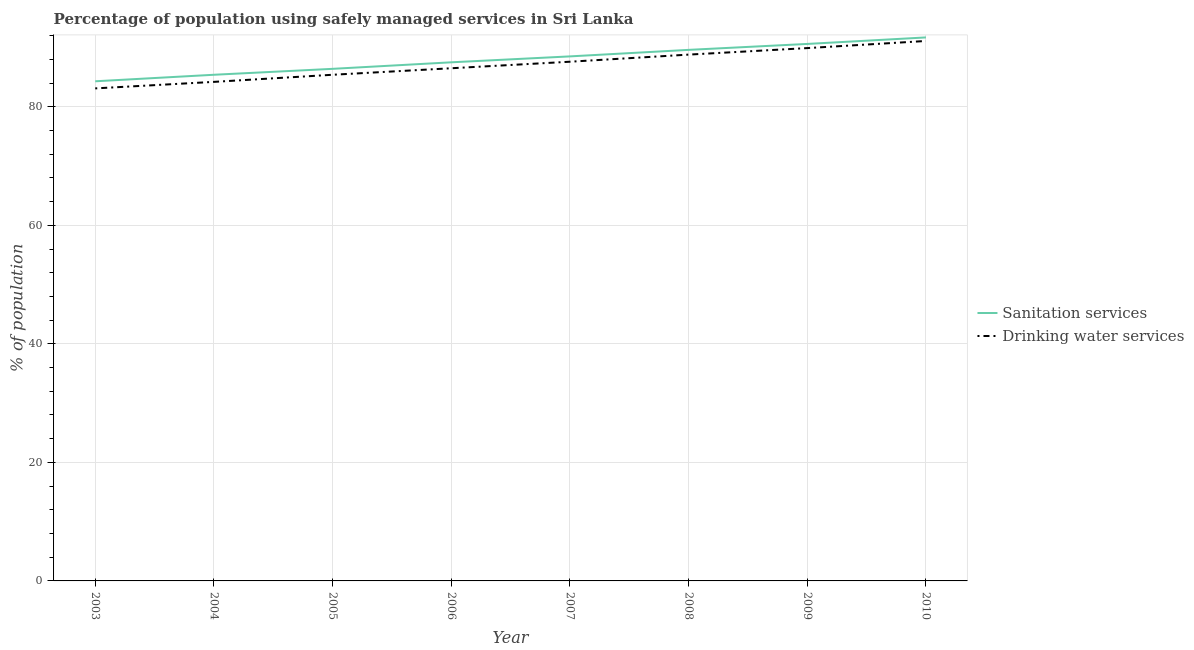Is the number of lines equal to the number of legend labels?
Your answer should be very brief. Yes. What is the percentage of population who used sanitation services in 2008?
Provide a short and direct response. 89.6. Across all years, what is the maximum percentage of population who used sanitation services?
Make the answer very short. 91.7. Across all years, what is the minimum percentage of population who used sanitation services?
Your response must be concise. 84.3. In which year was the percentage of population who used sanitation services minimum?
Provide a succinct answer. 2003. What is the total percentage of population who used drinking water services in the graph?
Offer a terse response. 696.6. What is the difference between the percentage of population who used sanitation services in 2003 and that in 2006?
Your answer should be compact. -3.2. What is the average percentage of population who used sanitation services per year?
Offer a very short reply. 88. In the year 2003, what is the difference between the percentage of population who used sanitation services and percentage of population who used drinking water services?
Keep it short and to the point. 1.2. What is the ratio of the percentage of population who used drinking water services in 2005 to that in 2008?
Make the answer very short. 0.96. Is the difference between the percentage of population who used drinking water services in 2005 and 2009 greater than the difference between the percentage of population who used sanitation services in 2005 and 2009?
Offer a terse response. No. What is the difference between the highest and the second highest percentage of population who used drinking water services?
Make the answer very short. 1.2. What is the difference between the highest and the lowest percentage of population who used sanitation services?
Offer a terse response. 7.4. Does the percentage of population who used sanitation services monotonically increase over the years?
Your answer should be very brief. Yes. Is the percentage of population who used drinking water services strictly greater than the percentage of population who used sanitation services over the years?
Your answer should be compact. No. How many lines are there?
Your answer should be compact. 2. Are the values on the major ticks of Y-axis written in scientific E-notation?
Your answer should be very brief. No. Does the graph contain grids?
Your response must be concise. Yes. What is the title of the graph?
Your answer should be very brief. Percentage of population using safely managed services in Sri Lanka. What is the label or title of the Y-axis?
Your answer should be compact. % of population. What is the % of population in Sanitation services in 2003?
Provide a short and direct response. 84.3. What is the % of population in Drinking water services in 2003?
Provide a short and direct response. 83.1. What is the % of population of Sanitation services in 2004?
Provide a short and direct response. 85.4. What is the % of population of Drinking water services in 2004?
Your response must be concise. 84.2. What is the % of population in Sanitation services in 2005?
Ensure brevity in your answer.  86.4. What is the % of population of Drinking water services in 2005?
Offer a very short reply. 85.4. What is the % of population in Sanitation services in 2006?
Offer a terse response. 87.5. What is the % of population in Drinking water services in 2006?
Your answer should be compact. 86.5. What is the % of population of Sanitation services in 2007?
Make the answer very short. 88.5. What is the % of population of Drinking water services in 2007?
Provide a succinct answer. 87.6. What is the % of population of Sanitation services in 2008?
Make the answer very short. 89.6. What is the % of population in Drinking water services in 2008?
Provide a succinct answer. 88.8. What is the % of population in Sanitation services in 2009?
Ensure brevity in your answer.  90.6. What is the % of population of Drinking water services in 2009?
Give a very brief answer. 89.9. What is the % of population of Sanitation services in 2010?
Make the answer very short. 91.7. What is the % of population in Drinking water services in 2010?
Keep it short and to the point. 91.1. Across all years, what is the maximum % of population of Sanitation services?
Your answer should be very brief. 91.7. Across all years, what is the maximum % of population of Drinking water services?
Provide a short and direct response. 91.1. Across all years, what is the minimum % of population in Sanitation services?
Keep it short and to the point. 84.3. Across all years, what is the minimum % of population in Drinking water services?
Your answer should be very brief. 83.1. What is the total % of population of Sanitation services in the graph?
Keep it short and to the point. 704. What is the total % of population of Drinking water services in the graph?
Keep it short and to the point. 696.6. What is the difference between the % of population in Sanitation services in 2003 and that in 2004?
Your answer should be compact. -1.1. What is the difference between the % of population in Drinking water services in 2003 and that in 2005?
Offer a terse response. -2.3. What is the difference between the % of population of Sanitation services in 2003 and that in 2006?
Offer a very short reply. -3.2. What is the difference between the % of population in Drinking water services in 2003 and that in 2006?
Make the answer very short. -3.4. What is the difference between the % of population of Sanitation services in 2003 and that in 2007?
Offer a very short reply. -4.2. What is the difference between the % of population in Drinking water services in 2003 and that in 2007?
Make the answer very short. -4.5. What is the difference between the % of population in Drinking water services in 2003 and that in 2009?
Make the answer very short. -6.8. What is the difference between the % of population in Sanitation services in 2004 and that in 2005?
Give a very brief answer. -1. What is the difference between the % of population in Sanitation services in 2004 and that in 2006?
Give a very brief answer. -2.1. What is the difference between the % of population of Sanitation services in 2004 and that in 2008?
Your answer should be compact. -4.2. What is the difference between the % of population of Drinking water services in 2004 and that in 2008?
Make the answer very short. -4.6. What is the difference between the % of population in Sanitation services in 2004 and that in 2009?
Offer a very short reply. -5.2. What is the difference between the % of population in Drinking water services in 2004 and that in 2010?
Provide a short and direct response. -6.9. What is the difference between the % of population of Sanitation services in 2005 and that in 2006?
Your answer should be very brief. -1.1. What is the difference between the % of population in Sanitation services in 2005 and that in 2008?
Provide a succinct answer. -3.2. What is the difference between the % of population in Sanitation services in 2005 and that in 2010?
Offer a terse response. -5.3. What is the difference between the % of population in Drinking water services in 2005 and that in 2010?
Offer a terse response. -5.7. What is the difference between the % of population of Drinking water services in 2006 and that in 2007?
Provide a short and direct response. -1.1. What is the difference between the % of population in Drinking water services in 2006 and that in 2008?
Make the answer very short. -2.3. What is the difference between the % of population of Sanitation services in 2006 and that in 2009?
Provide a short and direct response. -3.1. What is the difference between the % of population in Drinking water services in 2006 and that in 2009?
Offer a terse response. -3.4. What is the difference between the % of population of Sanitation services in 2007 and that in 2009?
Offer a very short reply. -2.1. What is the difference between the % of population in Sanitation services in 2007 and that in 2010?
Your answer should be compact. -3.2. What is the difference between the % of population in Sanitation services in 2008 and that in 2009?
Provide a succinct answer. -1. What is the difference between the % of population of Drinking water services in 2008 and that in 2009?
Ensure brevity in your answer.  -1.1. What is the difference between the % of population in Sanitation services in 2008 and that in 2010?
Your response must be concise. -2.1. What is the difference between the % of population of Drinking water services in 2008 and that in 2010?
Provide a short and direct response. -2.3. What is the difference between the % of population in Sanitation services in 2009 and that in 2010?
Your answer should be very brief. -1.1. What is the difference between the % of population in Sanitation services in 2003 and the % of population in Drinking water services in 2004?
Your response must be concise. 0.1. What is the difference between the % of population in Sanitation services in 2003 and the % of population in Drinking water services in 2008?
Make the answer very short. -4.5. What is the difference between the % of population of Sanitation services in 2003 and the % of population of Drinking water services in 2009?
Keep it short and to the point. -5.6. What is the difference between the % of population in Sanitation services in 2004 and the % of population in Drinking water services in 2005?
Provide a short and direct response. 0. What is the difference between the % of population in Sanitation services in 2004 and the % of population in Drinking water services in 2009?
Offer a terse response. -4.5. What is the difference between the % of population in Sanitation services in 2004 and the % of population in Drinking water services in 2010?
Your answer should be very brief. -5.7. What is the difference between the % of population of Sanitation services in 2005 and the % of population of Drinking water services in 2008?
Offer a very short reply. -2.4. What is the difference between the % of population of Sanitation services in 2006 and the % of population of Drinking water services in 2007?
Keep it short and to the point. -0.1. What is the difference between the % of population in Sanitation services in 2006 and the % of population in Drinking water services in 2008?
Your answer should be compact. -1.3. What is the difference between the % of population in Sanitation services in 2007 and the % of population in Drinking water services in 2008?
Your response must be concise. -0.3. What is the difference between the % of population in Sanitation services in 2007 and the % of population in Drinking water services in 2009?
Offer a terse response. -1.4. What is the average % of population of Drinking water services per year?
Your answer should be compact. 87.08. In the year 2004, what is the difference between the % of population in Sanitation services and % of population in Drinking water services?
Provide a succinct answer. 1.2. In the year 2007, what is the difference between the % of population in Sanitation services and % of population in Drinking water services?
Your response must be concise. 0.9. In the year 2008, what is the difference between the % of population in Sanitation services and % of population in Drinking water services?
Give a very brief answer. 0.8. In the year 2009, what is the difference between the % of population of Sanitation services and % of population of Drinking water services?
Keep it short and to the point. 0.7. In the year 2010, what is the difference between the % of population in Sanitation services and % of population in Drinking water services?
Ensure brevity in your answer.  0.6. What is the ratio of the % of population of Sanitation services in 2003 to that in 2004?
Make the answer very short. 0.99. What is the ratio of the % of population of Drinking water services in 2003 to that in 2004?
Provide a short and direct response. 0.99. What is the ratio of the % of population in Sanitation services in 2003 to that in 2005?
Your response must be concise. 0.98. What is the ratio of the % of population in Drinking water services in 2003 to that in 2005?
Give a very brief answer. 0.97. What is the ratio of the % of population of Sanitation services in 2003 to that in 2006?
Your answer should be very brief. 0.96. What is the ratio of the % of population in Drinking water services in 2003 to that in 2006?
Give a very brief answer. 0.96. What is the ratio of the % of population in Sanitation services in 2003 to that in 2007?
Your response must be concise. 0.95. What is the ratio of the % of population in Drinking water services in 2003 to that in 2007?
Give a very brief answer. 0.95. What is the ratio of the % of population of Sanitation services in 2003 to that in 2008?
Your answer should be compact. 0.94. What is the ratio of the % of population in Drinking water services in 2003 to that in 2008?
Your response must be concise. 0.94. What is the ratio of the % of population of Sanitation services in 2003 to that in 2009?
Your answer should be very brief. 0.93. What is the ratio of the % of population of Drinking water services in 2003 to that in 2009?
Provide a succinct answer. 0.92. What is the ratio of the % of population in Sanitation services in 2003 to that in 2010?
Provide a short and direct response. 0.92. What is the ratio of the % of population in Drinking water services in 2003 to that in 2010?
Make the answer very short. 0.91. What is the ratio of the % of population of Sanitation services in 2004 to that in 2005?
Keep it short and to the point. 0.99. What is the ratio of the % of population in Drinking water services in 2004 to that in 2005?
Keep it short and to the point. 0.99. What is the ratio of the % of population in Sanitation services in 2004 to that in 2006?
Your answer should be very brief. 0.98. What is the ratio of the % of population in Drinking water services in 2004 to that in 2006?
Keep it short and to the point. 0.97. What is the ratio of the % of population of Drinking water services in 2004 to that in 2007?
Your answer should be very brief. 0.96. What is the ratio of the % of population in Sanitation services in 2004 to that in 2008?
Your response must be concise. 0.95. What is the ratio of the % of population of Drinking water services in 2004 to that in 2008?
Provide a short and direct response. 0.95. What is the ratio of the % of population of Sanitation services in 2004 to that in 2009?
Your response must be concise. 0.94. What is the ratio of the % of population in Drinking water services in 2004 to that in 2009?
Provide a succinct answer. 0.94. What is the ratio of the % of population of Sanitation services in 2004 to that in 2010?
Offer a terse response. 0.93. What is the ratio of the % of population in Drinking water services in 2004 to that in 2010?
Offer a very short reply. 0.92. What is the ratio of the % of population of Sanitation services in 2005 to that in 2006?
Provide a short and direct response. 0.99. What is the ratio of the % of population in Drinking water services in 2005 to that in 2006?
Your response must be concise. 0.99. What is the ratio of the % of population of Sanitation services in 2005 to that in 2007?
Give a very brief answer. 0.98. What is the ratio of the % of population in Drinking water services in 2005 to that in 2007?
Ensure brevity in your answer.  0.97. What is the ratio of the % of population of Drinking water services in 2005 to that in 2008?
Your response must be concise. 0.96. What is the ratio of the % of population in Sanitation services in 2005 to that in 2009?
Your answer should be compact. 0.95. What is the ratio of the % of population in Drinking water services in 2005 to that in 2009?
Make the answer very short. 0.95. What is the ratio of the % of population in Sanitation services in 2005 to that in 2010?
Provide a short and direct response. 0.94. What is the ratio of the % of population in Drinking water services in 2005 to that in 2010?
Make the answer very short. 0.94. What is the ratio of the % of population of Sanitation services in 2006 to that in 2007?
Your response must be concise. 0.99. What is the ratio of the % of population in Drinking water services in 2006 to that in 2007?
Keep it short and to the point. 0.99. What is the ratio of the % of population in Sanitation services in 2006 to that in 2008?
Provide a short and direct response. 0.98. What is the ratio of the % of population of Drinking water services in 2006 to that in 2008?
Ensure brevity in your answer.  0.97. What is the ratio of the % of population of Sanitation services in 2006 to that in 2009?
Your answer should be compact. 0.97. What is the ratio of the % of population in Drinking water services in 2006 to that in 2009?
Your response must be concise. 0.96. What is the ratio of the % of population of Sanitation services in 2006 to that in 2010?
Your answer should be very brief. 0.95. What is the ratio of the % of population in Drinking water services in 2006 to that in 2010?
Make the answer very short. 0.95. What is the ratio of the % of population in Drinking water services in 2007 to that in 2008?
Your answer should be compact. 0.99. What is the ratio of the % of population of Sanitation services in 2007 to that in 2009?
Your response must be concise. 0.98. What is the ratio of the % of population in Drinking water services in 2007 to that in 2009?
Offer a very short reply. 0.97. What is the ratio of the % of population in Sanitation services in 2007 to that in 2010?
Offer a very short reply. 0.97. What is the ratio of the % of population of Drinking water services in 2007 to that in 2010?
Ensure brevity in your answer.  0.96. What is the ratio of the % of population of Sanitation services in 2008 to that in 2009?
Provide a succinct answer. 0.99. What is the ratio of the % of population in Drinking water services in 2008 to that in 2009?
Your answer should be very brief. 0.99. What is the ratio of the % of population of Sanitation services in 2008 to that in 2010?
Give a very brief answer. 0.98. What is the ratio of the % of population in Drinking water services in 2008 to that in 2010?
Make the answer very short. 0.97. What is the ratio of the % of population in Sanitation services in 2009 to that in 2010?
Give a very brief answer. 0.99. What is the ratio of the % of population of Drinking water services in 2009 to that in 2010?
Offer a very short reply. 0.99. What is the difference between the highest and the second highest % of population of Sanitation services?
Keep it short and to the point. 1.1. What is the difference between the highest and the lowest % of population of Drinking water services?
Give a very brief answer. 8. 